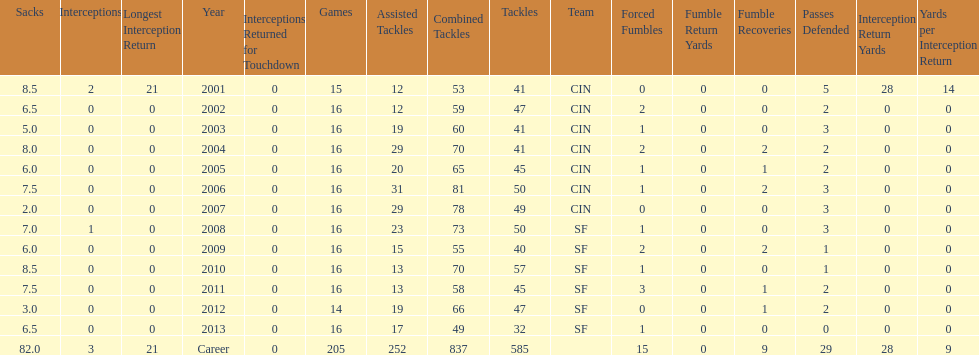How many seasons had combined tackles of 70 or more? 5. 